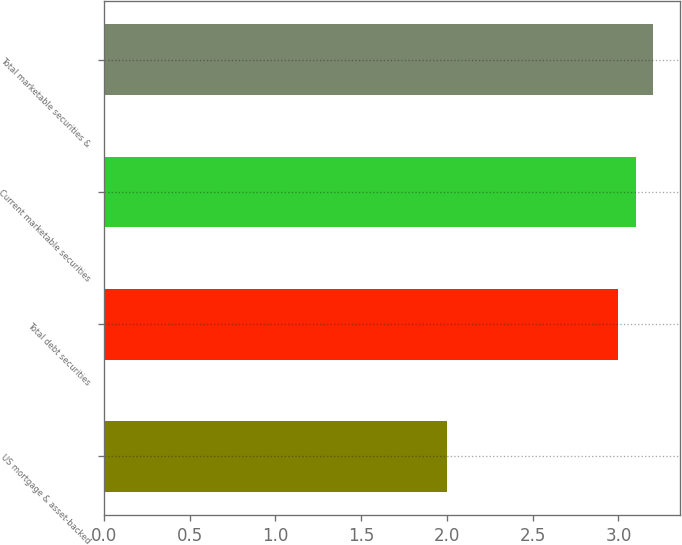Convert chart to OTSL. <chart><loc_0><loc_0><loc_500><loc_500><bar_chart><fcel>US mortgage & asset-backed<fcel>Total debt securities<fcel>Current marketable securities<fcel>Total marketable securities &<nl><fcel>2<fcel>3<fcel>3.1<fcel>3.2<nl></chart> 